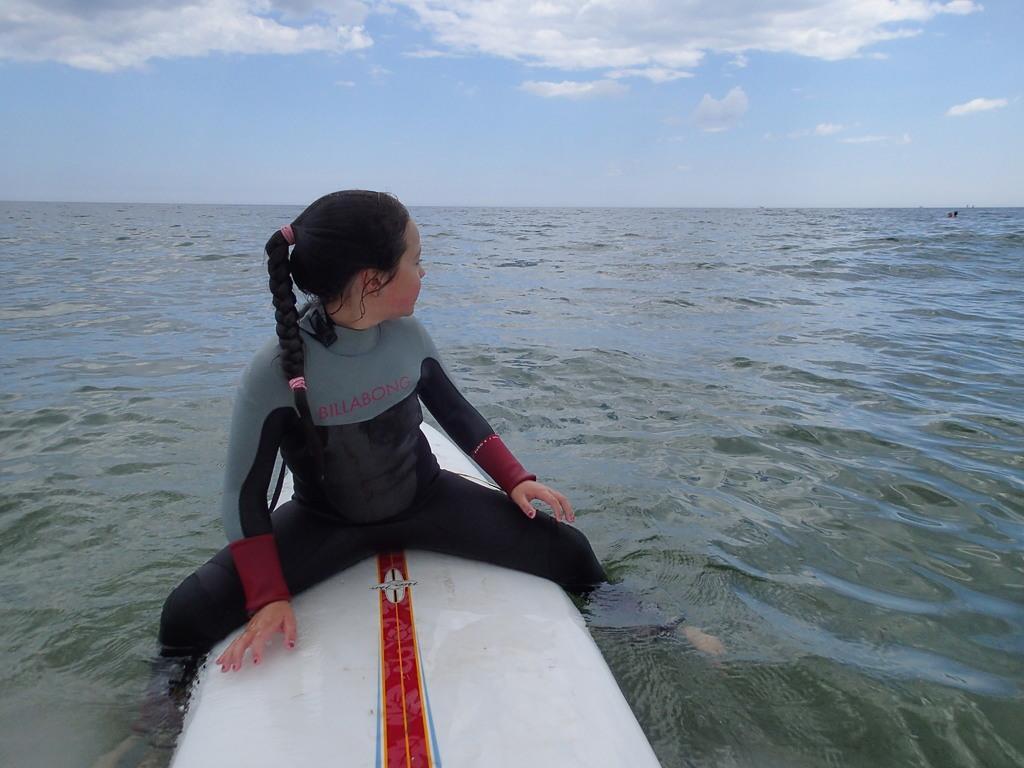Describe this image in one or two sentences. This picture is taken in an ocean. At the bottom, there is a girl sitting on the board which is on the water. She is wearing grey and black clothes. On the top, there is a sky with clouds. 